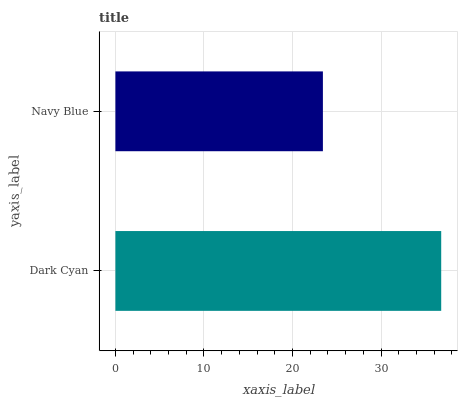Is Navy Blue the minimum?
Answer yes or no. Yes. Is Dark Cyan the maximum?
Answer yes or no. Yes. Is Navy Blue the maximum?
Answer yes or no. No. Is Dark Cyan greater than Navy Blue?
Answer yes or no. Yes. Is Navy Blue less than Dark Cyan?
Answer yes or no. Yes. Is Navy Blue greater than Dark Cyan?
Answer yes or no. No. Is Dark Cyan less than Navy Blue?
Answer yes or no. No. Is Dark Cyan the high median?
Answer yes or no. Yes. Is Navy Blue the low median?
Answer yes or no. Yes. Is Navy Blue the high median?
Answer yes or no. No. Is Dark Cyan the low median?
Answer yes or no. No. 